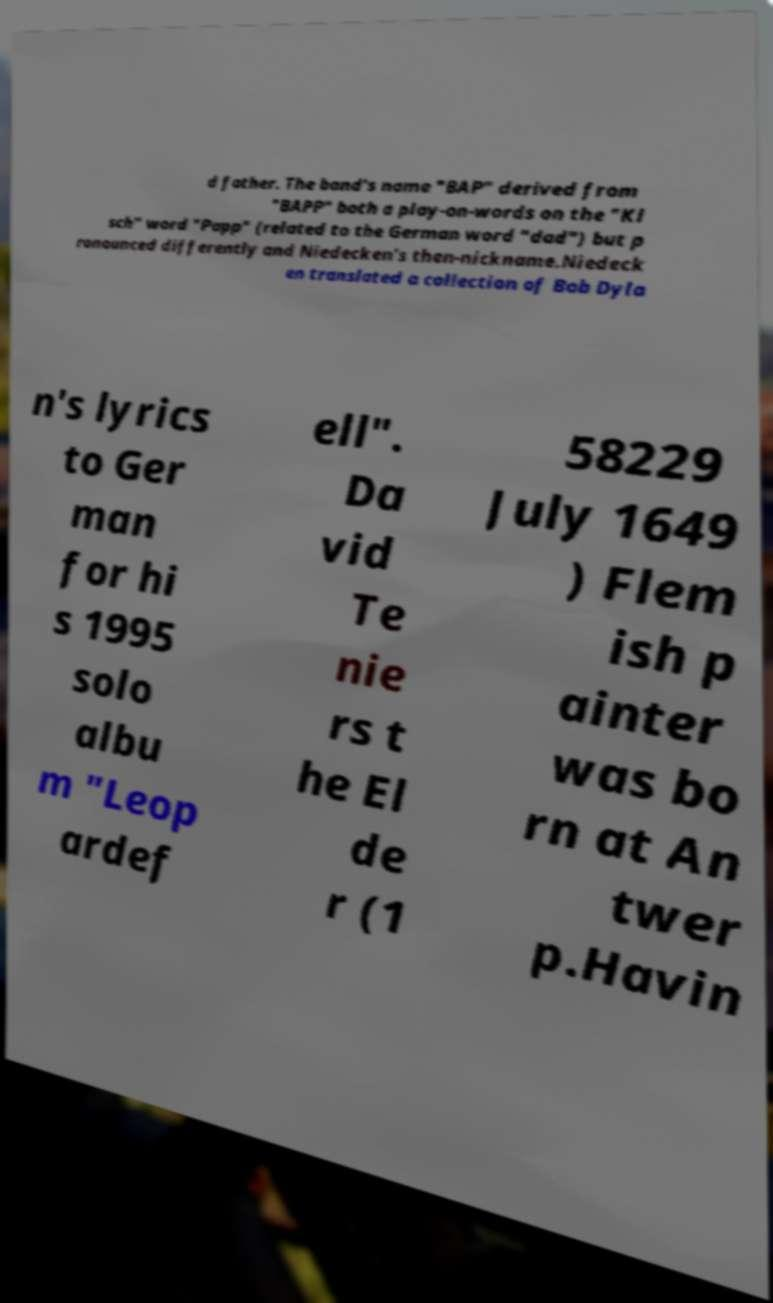Can you read and provide the text displayed in the image?This photo seems to have some interesting text. Can you extract and type it out for me? d father. The band's name "BAP" derived from "BAPP" both a play-on-words on the "Kl sch" word "Papp" (related to the German word "dad") but p ronounced differently and Niedecken's then-nickname.Niedeck en translated a collection of Bob Dyla n's lyrics to Ger man for hi s 1995 solo albu m "Leop ardef ell". Da vid Te nie rs t he El de r (1 58229 July 1649 ) Flem ish p ainter was bo rn at An twer p.Havin 